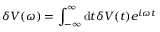Convert formula to latex. <formula><loc_0><loc_0><loc_500><loc_500>\delta V ( \omega ) = \int _ { - \infty } ^ { \infty } d t \delta V ( t ) e ^ { i \omega t }</formula> 